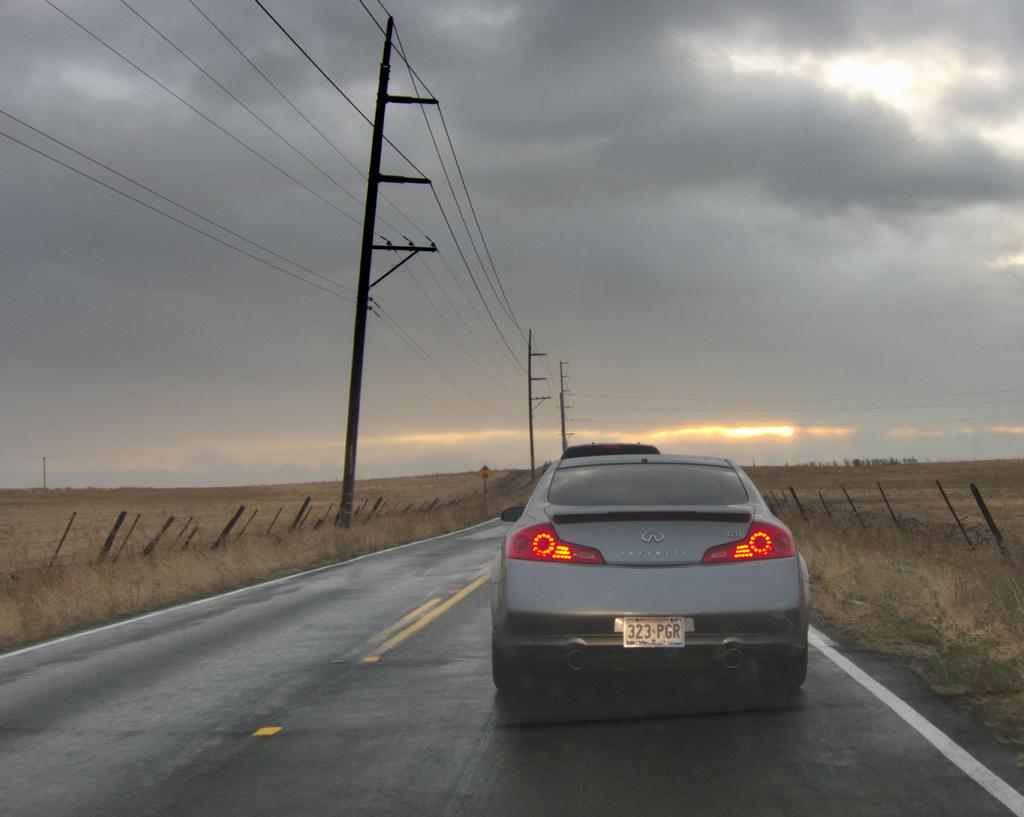What is the main subject of the image? There is a car on the road in the image. What type of vegetation can be seen in the image? There is grass visible in the image. What structures are present in the image? There are poles and a board in the image. What is visible in the background of the image? The sky is visible in the background of the image. What is attached to the poles in the image? Wires are present in the image, attached to the poles. What can be seen in the sky? Clouds are present in the sky. What news is being broadcasted from the board in the image? There is no news broadcasted from the board in the image. The board is a separate object in the image, and there is no indication of any news being broadcasted from it. 